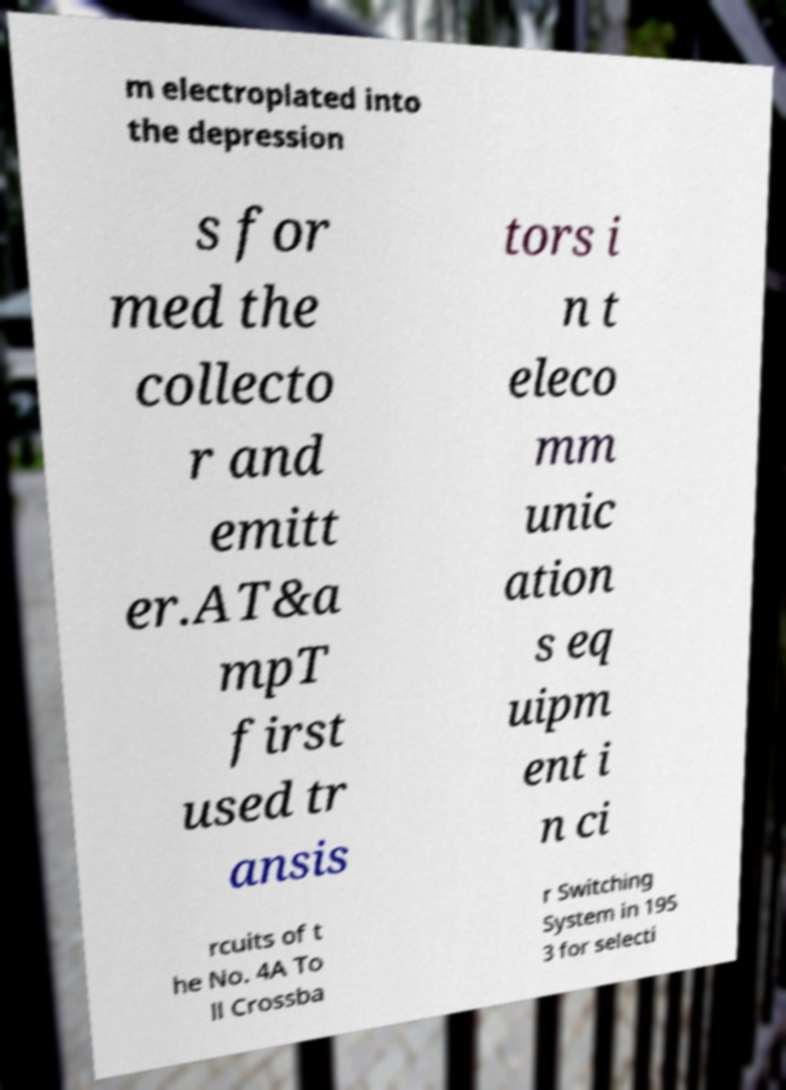Could you extract and type out the text from this image? m electroplated into the depression s for med the collecto r and emitt er.AT&a mpT first used tr ansis tors i n t eleco mm unic ation s eq uipm ent i n ci rcuits of t he No. 4A To ll Crossba r Switching System in 195 3 for selecti 